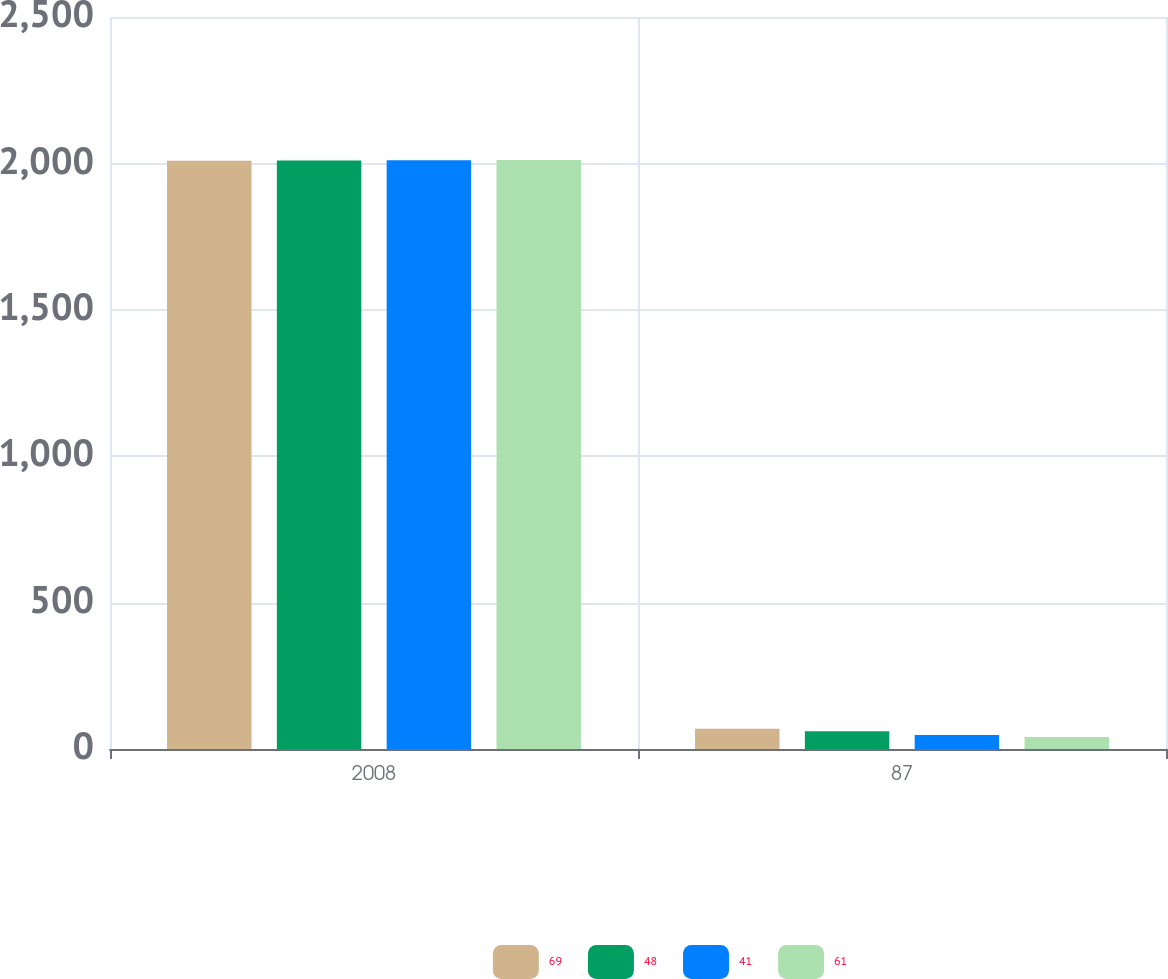Convert chart. <chart><loc_0><loc_0><loc_500><loc_500><stacked_bar_chart><ecel><fcel>2008<fcel>87<nl><fcel>69<fcel>2009<fcel>69<nl><fcel>48<fcel>2010<fcel>61<nl><fcel>41<fcel>2011<fcel>48<nl><fcel>61<fcel>2012<fcel>41<nl></chart> 